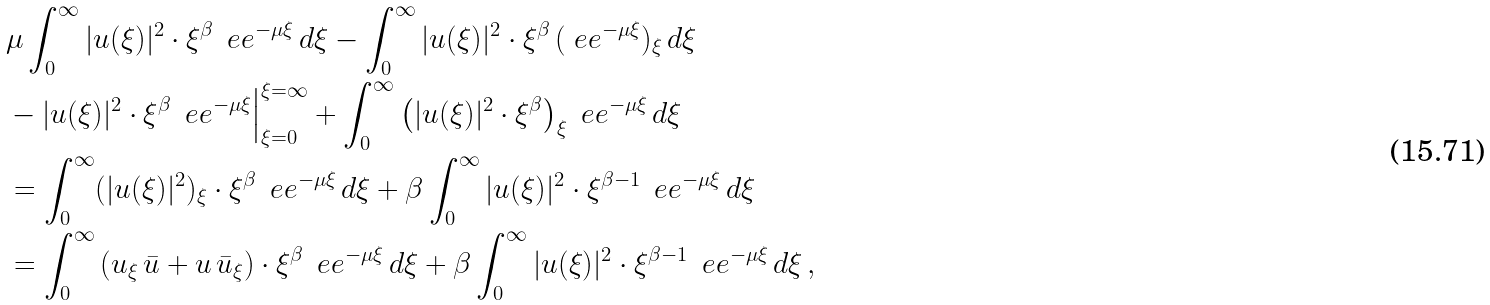<formula> <loc_0><loc_0><loc_500><loc_500>& \mu \int _ { 0 } ^ { \infty } | u ( \xi ) | ^ { 2 } \cdot \xi ^ { \beta } \, \ e e ^ { - \mu \xi } \, d \xi - \int _ { 0 } ^ { \infty } | u ( \xi ) | ^ { 2 } \cdot \xi ^ { \beta } \, ( \ e e ^ { - \mu \xi } ) _ { \xi } \, d \xi \\ & - | u ( \xi ) | ^ { 2 } \cdot \xi ^ { \beta } \, \ e e ^ { - \mu \xi } \Big | _ { \xi = 0 } ^ { \xi = \infty } + \int _ { 0 } ^ { \infty } \left ( | u ( \xi ) | ^ { 2 } \cdot \xi ^ { \beta } \right ) _ { \xi } \ e e ^ { - \mu \xi } \, d \xi \\ & = \int _ { 0 } ^ { \infty } ( | u ( \xi ) | ^ { 2 } ) _ { \xi } \cdot \xi ^ { \beta } \, \ e e ^ { - \mu \xi } \, d \xi + \beta \int _ { 0 } ^ { \infty } | u ( \xi ) | ^ { 2 } \cdot \xi ^ { \beta - 1 } \, \ e e ^ { - \mu \xi } \, d \xi \\ & = \int _ { 0 } ^ { \infty } \left ( u _ { \xi } \, \bar { u } + u \, \bar { u } _ { \xi } \right ) \cdot \xi ^ { \beta } \, \ e e ^ { - \mu \xi } \, d \xi + \beta \int _ { 0 } ^ { \infty } | u ( \xi ) | ^ { 2 } \cdot \xi ^ { \beta - 1 } \, \ e e ^ { - \mu \xi } \, d \xi \, ,</formula> 